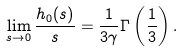<formula> <loc_0><loc_0><loc_500><loc_500>\lim _ { s \rightarrow 0 } \frac { h _ { 0 } ( s ) } { s } = \frac { 1 } { 3 \gamma } \Gamma \left ( \frac { 1 } { 3 } \right ) .</formula> 